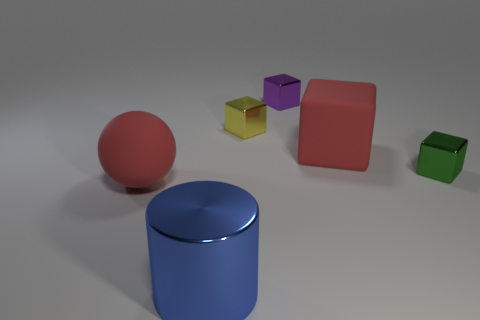How big is the blue cylinder?
Ensure brevity in your answer.  Large. There is a large red object to the left of the red thing that is behind the green shiny object; what is its material?
Give a very brief answer. Rubber. There is a red matte thing that is on the left side of the blue thing; does it have the same size as the green metal cube?
Your answer should be very brief. No. Is there a large rubber thing that has the same color as the big block?
Offer a very short reply. Yes. What number of objects are large objects that are in front of the big red sphere or tiny yellow blocks behind the large cube?
Offer a very short reply. 2. Does the big shiny object have the same color as the matte block?
Give a very brief answer. No. There is a thing that is the same color as the ball; what is it made of?
Provide a short and direct response. Rubber. Is the number of metal cylinders that are in front of the yellow metal object less than the number of small yellow objects behind the large matte block?
Provide a short and direct response. No. Is the big red cube made of the same material as the small purple cube?
Keep it short and to the point. No. There is a object that is left of the yellow object and on the right side of the red ball; what is its size?
Your response must be concise. Large. 